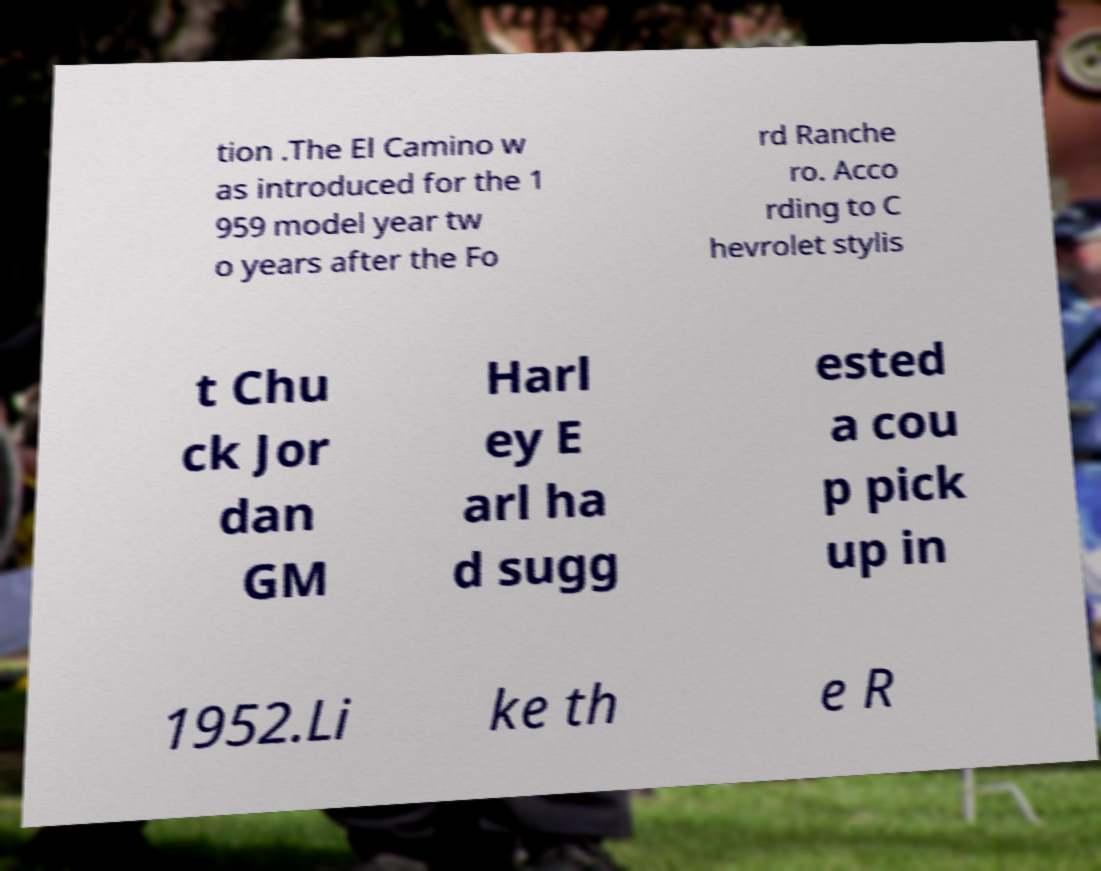I need the written content from this picture converted into text. Can you do that? tion .The El Camino w as introduced for the 1 959 model year tw o years after the Fo rd Ranche ro. Acco rding to C hevrolet stylis t Chu ck Jor dan GM Harl ey E arl ha d sugg ested a cou p pick up in 1952.Li ke th e R 